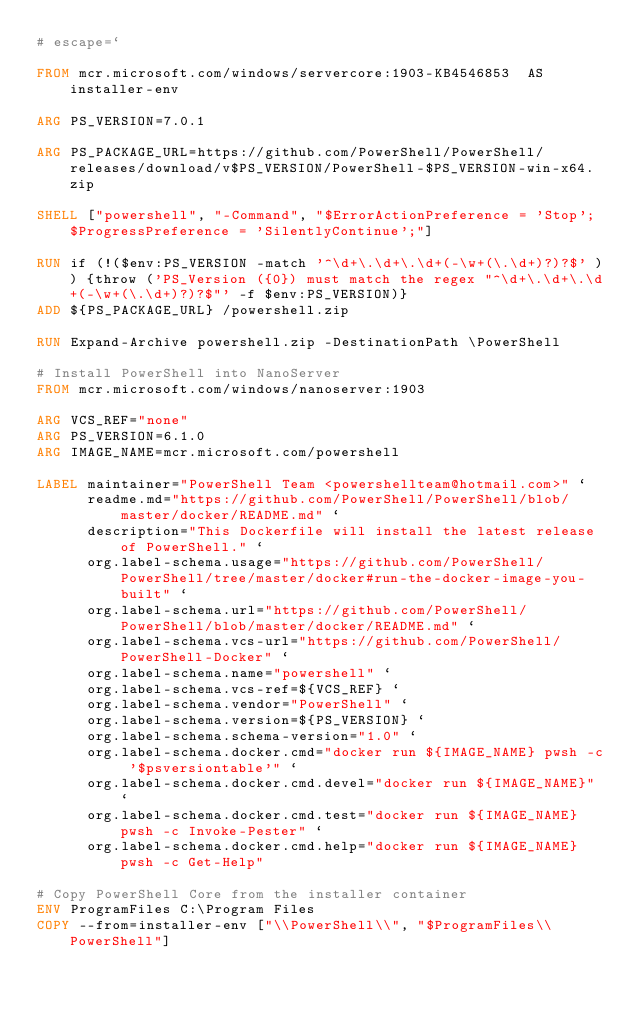Convert code to text. <code><loc_0><loc_0><loc_500><loc_500><_Dockerfile_># escape=`

FROM mcr.microsoft.com/windows/servercore:1903-KB4546853  AS installer-env

ARG PS_VERSION=7.0.1

ARG PS_PACKAGE_URL=https://github.com/PowerShell/PowerShell/releases/download/v$PS_VERSION/PowerShell-$PS_VERSION-win-x64.zip

SHELL ["powershell", "-Command", "$ErrorActionPreference = 'Stop'; $ProgressPreference = 'SilentlyContinue';"]

RUN if (!($env:PS_VERSION -match '^\d+\.\d+\.\d+(-\w+(\.\d+)?)?$' )) {throw ('PS_Version ({0}) must match the regex "^\d+\.\d+\.\d+(-\w+(\.\d+)?)?$"' -f $env:PS_VERSION)}
ADD ${PS_PACKAGE_URL} /powershell.zip

RUN Expand-Archive powershell.zip -DestinationPath \PowerShell

# Install PowerShell into NanoServer
FROM mcr.microsoft.com/windows/nanoserver:1903

ARG VCS_REF="none"
ARG PS_VERSION=6.1.0
ARG IMAGE_NAME=mcr.microsoft.com/powershell

LABEL maintainer="PowerShell Team <powershellteam@hotmail.com>" `
      readme.md="https://github.com/PowerShell/PowerShell/blob/master/docker/README.md" `
      description="This Dockerfile will install the latest release of PowerShell." `
      org.label-schema.usage="https://github.com/PowerShell/PowerShell/tree/master/docker#run-the-docker-image-you-built" `
      org.label-schema.url="https://github.com/PowerShell/PowerShell/blob/master/docker/README.md" `
      org.label-schema.vcs-url="https://github.com/PowerShell/PowerShell-Docker" `
      org.label-schema.name="powershell" `
      org.label-schema.vcs-ref=${VCS_REF} `
      org.label-schema.vendor="PowerShell" `
      org.label-schema.version=${PS_VERSION} `
      org.label-schema.schema-version="1.0" `
      org.label-schema.docker.cmd="docker run ${IMAGE_NAME} pwsh -c '$psversiontable'" `
      org.label-schema.docker.cmd.devel="docker run ${IMAGE_NAME}" `
      org.label-schema.docker.cmd.test="docker run ${IMAGE_NAME} pwsh -c Invoke-Pester" `
      org.label-schema.docker.cmd.help="docker run ${IMAGE_NAME} pwsh -c Get-Help"

# Copy PowerShell Core from the installer container
ENV ProgramFiles C:\Program Files
COPY --from=installer-env ["\\PowerShell\\", "$ProgramFiles\\PowerShell"]
</code> 